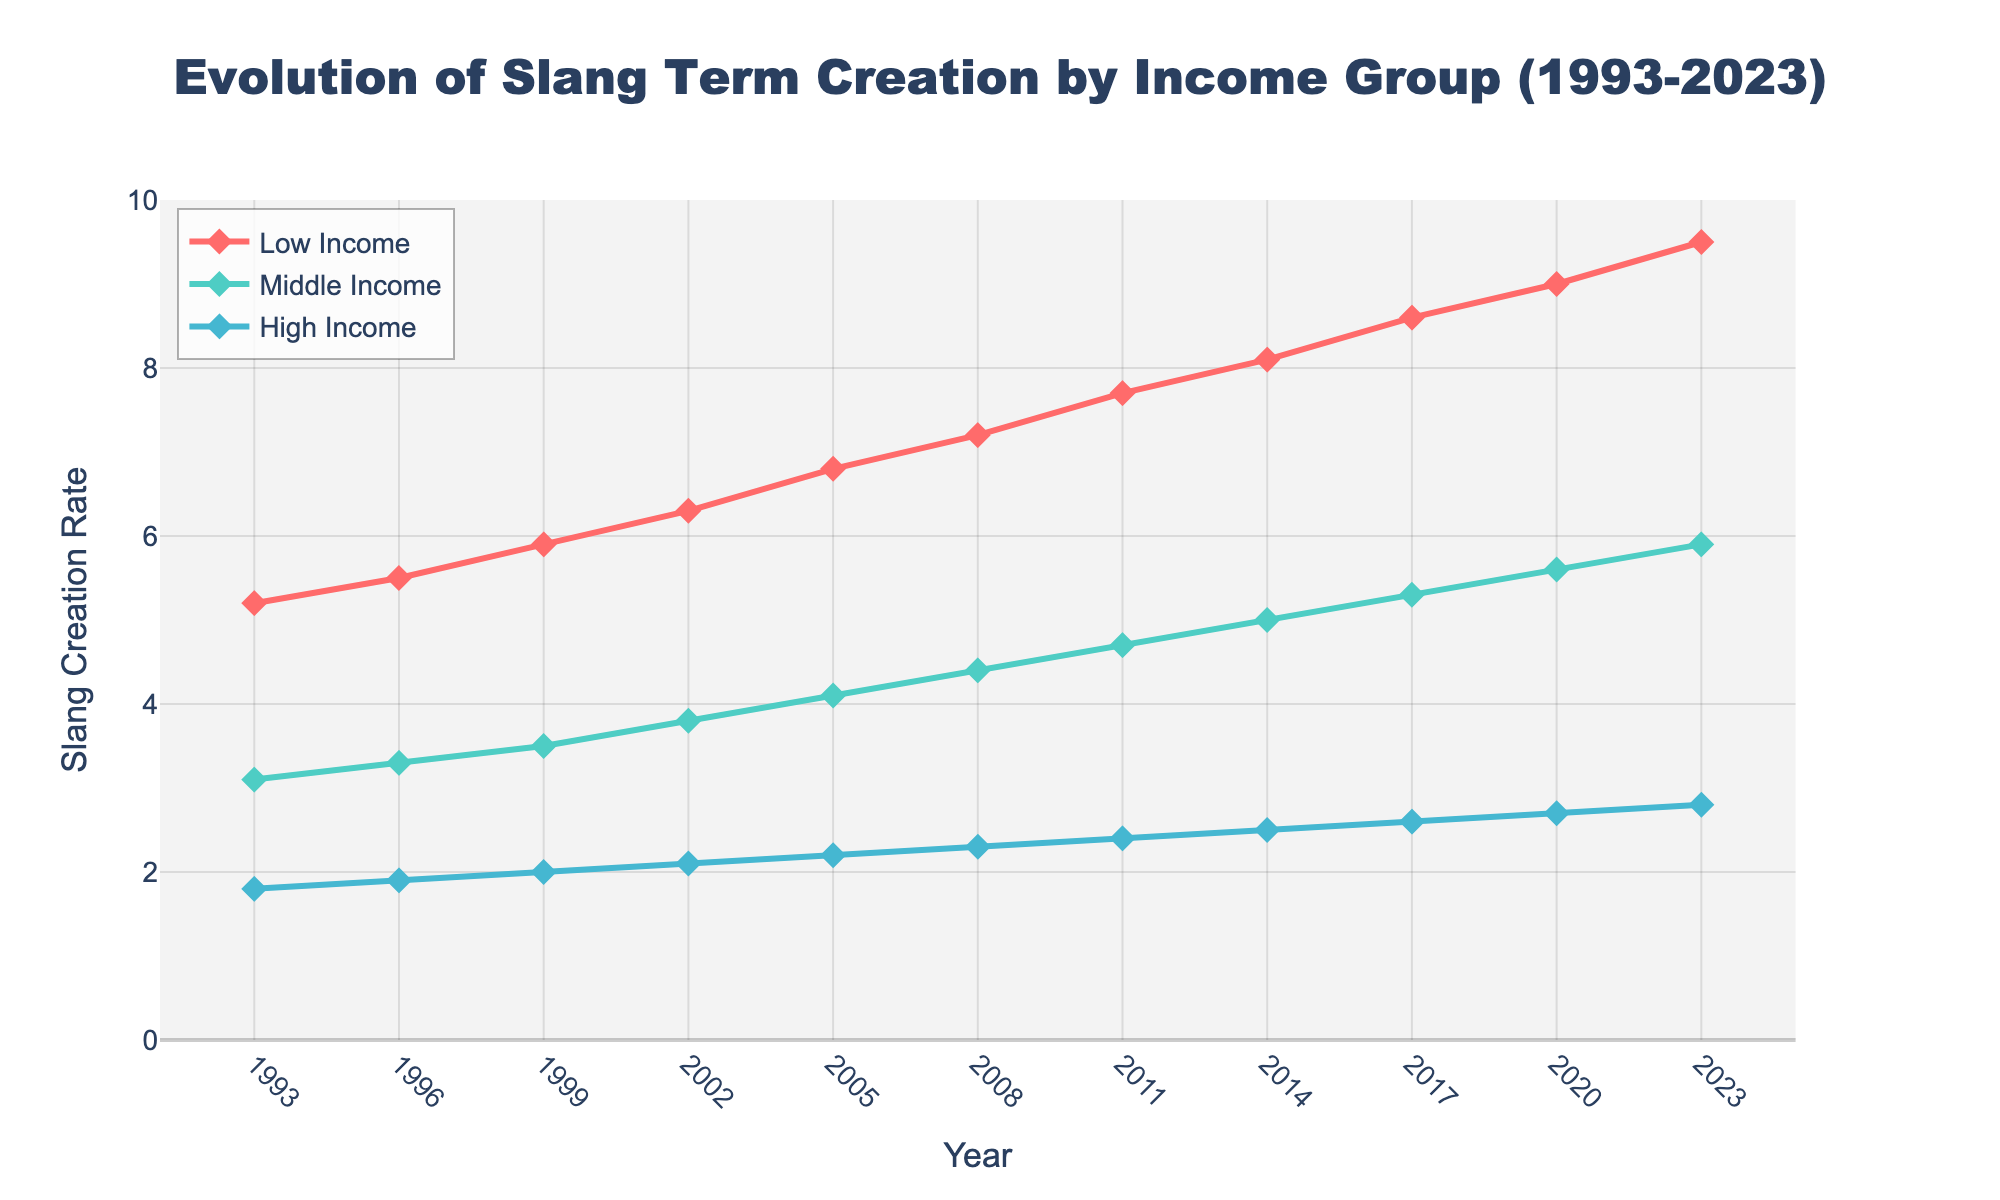What's the trend in slang creation for low-income communities over the past 30 years? The line for low-income slang creation is consistently upward trending from 5.2 in 1993 to 9.5 in 2023, indicating a continuous increase.
Answer: Increasing In which year do middle-income communities see a slang creation rate of exactly 5.0? By examining the middle-income data points on the figure, 2014 is the year when the slang creation rate is exactly 5.0.
Answer: 2014 How does the slang creation rate in high-income communities in 1999 compare to middle-income communities in the same year? Looking at the 1999 data, high-income has a value of 2.0 while middle-income has 3.5. Thus, the middle-income slang creation rate is significantly higher.
Answer: Middle-income is higher What is the difference in slang creation rates between low-income and high-income communities in 2023? For 2023, low-income has a value of 9.5 and high-income has 2.8. Subtracting these gives 9.5 - 2.8 = 6.7.
Answer: 6.7 Which income group shows the highest rate of slang term creation throughout the 30 years? The plot clearly shows that the low-income group has consistently higher values compared to middle and high-income groups across all years.
Answer: Low-income group What is the average slang creation rate for middle-income communities over the period 1993 to 2023? The slang creation rates for middle-income from 1993 to 2023 are [3.1, 3.3, 3.5, 3.8, 4.1, 4.4, 4.7, 5.0, 5.3, 5.6, 5.9]. Summing these gives 48.7, and dividing by 11 (number of years) gives 48.7 / 11 ≈ 4.43.
Answer: 4.43 Compare the rate of increase in slang creation between low-income and middle-income communities from 1993 to 2023. For low-income, the rate increased from 5.2 to 9.5 (an increase of 4.3). For middle-income, it increased from 3.1 to 5.9 (an increase of 2.8). Therefore, the low-income rate increased more significantly.
Answer: Low-income increased more In what year did high-income communities reach a slang creation rate of 2.5? According to the chart, high-income communities reached a slang creation rate of 2.5 in 2014.
Answer: 2014 What is the combined slang creation rate for all three income groups in the year 2005? The rates in 2005 are: Low-income - 6.8, Middle-income - 4.1, High-income - 2.2. Adding these together gives 6.8 + 4.1 + 2.2 = 13.1.
Answer: 13.1 Which income group's slang creation rate showed the most considerable growth from 2017 to 2023? From 2017 to 2023, low-income increased from 8.6 to 9.5 (an increase of 0.9), middle-income from 5.3 to 5.9 (an increase of 0.6), and high-income from 2.6 to 2.8 (an increase of 0.2). Thus, the low-income group showed the most considerable growth.
Answer: Low-income 